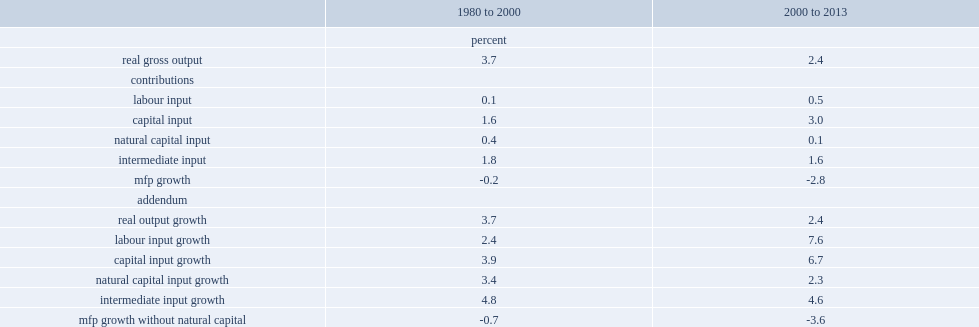What's the percent of natural capital input from 1980 to 2000. 0.4. What's the percent of annual growth in gross output in oil and gas extraction from 1980 to 2000? 3.7. What's the percent of natural capital input from 2000 to 2013? 0.1. What's the percent of annual growth in gross output in oil and gas extraction from 2000 to 2013? 2.4. What's the percent that mfp growth without natural capital was declined in the period from 1980 to 2000? 0.7. What'sthe percent that mfp growth without natural capital fell in the period from 2000 to 2013? 3.6. What's the percent that this translates into a slowdown in mfp growth over the two periods. 2.9. 